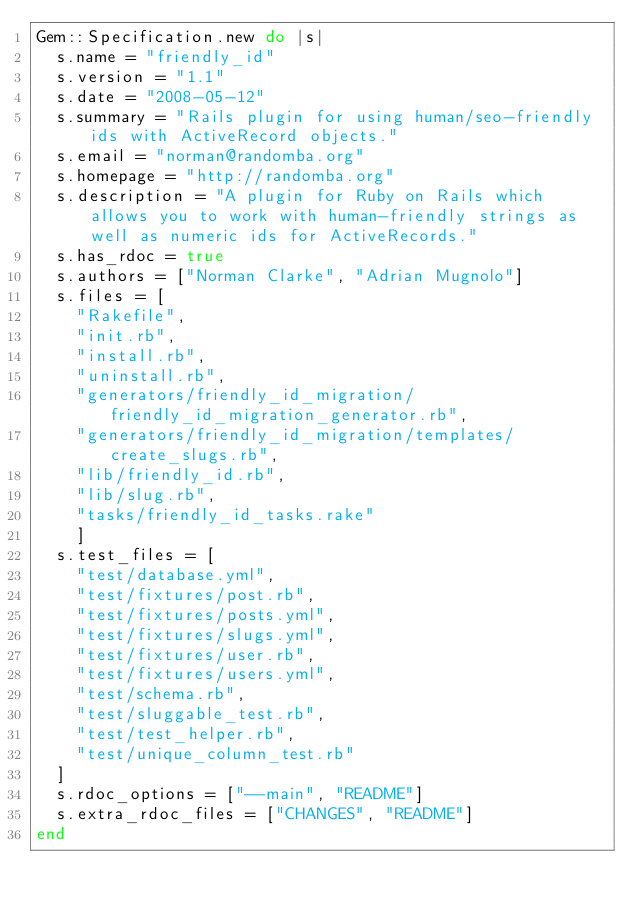Convert code to text. <code><loc_0><loc_0><loc_500><loc_500><_Ruby_>Gem::Specification.new do |s|
  s.name = "friendly_id"
  s.version = "1.1"
  s.date = "2008-05-12"
  s.summary = "Rails plugin for using human/seo-friendly ids with ActiveRecord objects."
  s.email = "norman@randomba.org"
  s.homepage = "http://randomba.org"
  s.description = "A plugin for Ruby on Rails which allows you to work with human-friendly strings as well as numeric ids for ActiveRecords."
  s.has_rdoc = true
  s.authors = ["Norman Clarke", "Adrian Mugnolo"]
  s.files = [
    "Rakefile",
    "init.rb",
    "install.rb",
    "uninstall.rb",
    "generators/friendly_id_migration/friendly_id_migration_generator.rb",
    "generators/friendly_id_migration/templates/create_slugs.rb",
    "lib/friendly_id.rb",
    "lib/slug.rb",
    "tasks/friendly_id_tasks.rake"    
    ]
  s.test_files = [
    "test/database.yml",
    "test/fixtures/post.rb",
    "test/fixtures/posts.yml",
    "test/fixtures/slugs.yml",
    "test/fixtures/user.rb",
    "test/fixtures/users.yml",
    "test/schema.rb",
    "test/sluggable_test.rb",
    "test/test_helper.rb",
    "test/unique_column_test.rb"
  ]
  s.rdoc_options = ["--main", "README"]
  s.extra_rdoc_files = ["CHANGES", "README"]
end</code> 